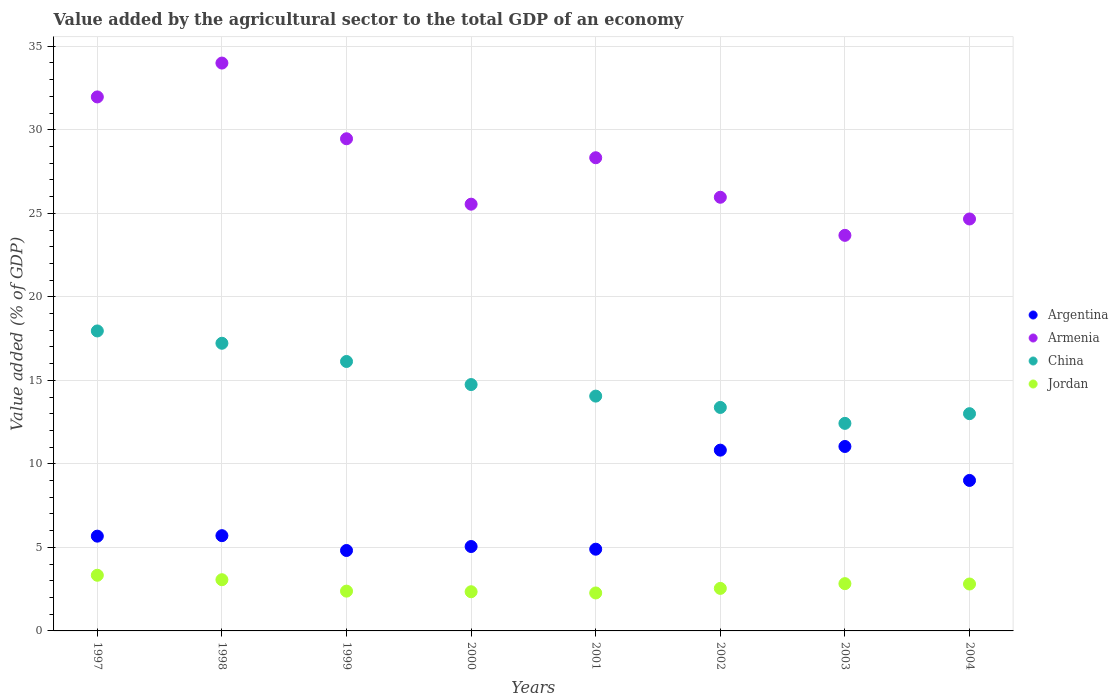What is the value added by the agricultural sector to the total GDP in Jordan in 2000?
Keep it short and to the point. 2.35. Across all years, what is the maximum value added by the agricultural sector to the total GDP in Armenia?
Your answer should be compact. 34. Across all years, what is the minimum value added by the agricultural sector to the total GDP in Jordan?
Your answer should be very brief. 2.27. In which year was the value added by the agricultural sector to the total GDP in Argentina minimum?
Provide a short and direct response. 1999. What is the total value added by the agricultural sector to the total GDP in Armenia in the graph?
Provide a succinct answer. 223.61. What is the difference between the value added by the agricultural sector to the total GDP in China in 1997 and that in 2004?
Your answer should be compact. 4.95. What is the difference between the value added by the agricultural sector to the total GDP in Argentina in 1998 and the value added by the agricultural sector to the total GDP in Armenia in 2004?
Your answer should be compact. -18.96. What is the average value added by the agricultural sector to the total GDP in Argentina per year?
Your answer should be very brief. 7.13. In the year 2003, what is the difference between the value added by the agricultural sector to the total GDP in Argentina and value added by the agricultural sector to the total GDP in Jordan?
Provide a short and direct response. 8.21. In how many years, is the value added by the agricultural sector to the total GDP in China greater than 22 %?
Ensure brevity in your answer.  0. What is the ratio of the value added by the agricultural sector to the total GDP in China in 1997 to that in 2003?
Ensure brevity in your answer.  1.45. Is the value added by the agricultural sector to the total GDP in China in 1997 less than that in 1998?
Your response must be concise. No. Is the difference between the value added by the agricultural sector to the total GDP in Argentina in 1998 and 2004 greater than the difference between the value added by the agricultural sector to the total GDP in Jordan in 1998 and 2004?
Your response must be concise. No. What is the difference between the highest and the second highest value added by the agricultural sector to the total GDP in Argentina?
Your answer should be very brief. 0.22. What is the difference between the highest and the lowest value added by the agricultural sector to the total GDP in China?
Ensure brevity in your answer.  5.53. In how many years, is the value added by the agricultural sector to the total GDP in Armenia greater than the average value added by the agricultural sector to the total GDP in Armenia taken over all years?
Provide a short and direct response. 4. Is the sum of the value added by the agricultural sector to the total GDP in Argentina in 2000 and 2004 greater than the maximum value added by the agricultural sector to the total GDP in China across all years?
Your response must be concise. No. Is it the case that in every year, the sum of the value added by the agricultural sector to the total GDP in Argentina and value added by the agricultural sector to the total GDP in Jordan  is greater than the sum of value added by the agricultural sector to the total GDP in Armenia and value added by the agricultural sector to the total GDP in China?
Your answer should be very brief. Yes. Is the value added by the agricultural sector to the total GDP in Argentina strictly less than the value added by the agricultural sector to the total GDP in China over the years?
Your answer should be very brief. Yes. How many years are there in the graph?
Your response must be concise. 8. What is the difference between two consecutive major ticks on the Y-axis?
Your response must be concise. 5. Does the graph contain any zero values?
Provide a succinct answer. No. Where does the legend appear in the graph?
Offer a very short reply. Center right. How many legend labels are there?
Make the answer very short. 4. How are the legend labels stacked?
Give a very brief answer. Vertical. What is the title of the graph?
Offer a terse response. Value added by the agricultural sector to the total GDP of an economy. What is the label or title of the Y-axis?
Provide a succinct answer. Value added (% of GDP). What is the Value added (% of GDP) of Argentina in 1997?
Make the answer very short. 5.67. What is the Value added (% of GDP) in Armenia in 1997?
Keep it short and to the point. 31.97. What is the Value added (% of GDP) of China in 1997?
Your answer should be compact. 17.96. What is the Value added (% of GDP) in Jordan in 1997?
Provide a succinct answer. 3.33. What is the Value added (% of GDP) in Argentina in 1998?
Give a very brief answer. 5.7. What is the Value added (% of GDP) in Armenia in 1998?
Your answer should be very brief. 34. What is the Value added (% of GDP) of China in 1998?
Your response must be concise. 17.22. What is the Value added (% of GDP) of Jordan in 1998?
Offer a terse response. 3.07. What is the Value added (% of GDP) of Argentina in 1999?
Offer a very short reply. 4.82. What is the Value added (% of GDP) in Armenia in 1999?
Ensure brevity in your answer.  29.46. What is the Value added (% of GDP) of China in 1999?
Give a very brief answer. 16.13. What is the Value added (% of GDP) of Jordan in 1999?
Keep it short and to the point. 2.38. What is the Value added (% of GDP) of Argentina in 2000?
Provide a succinct answer. 5.05. What is the Value added (% of GDP) of Armenia in 2000?
Make the answer very short. 25.55. What is the Value added (% of GDP) of China in 2000?
Offer a very short reply. 14.75. What is the Value added (% of GDP) of Jordan in 2000?
Provide a short and direct response. 2.35. What is the Value added (% of GDP) in Argentina in 2001?
Make the answer very short. 4.89. What is the Value added (% of GDP) of Armenia in 2001?
Your answer should be compact. 28.33. What is the Value added (% of GDP) in China in 2001?
Your answer should be compact. 14.06. What is the Value added (% of GDP) in Jordan in 2001?
Provide a short and direct response. 2.27. What is the Value added (% of GDP) of Argentina in 2002?
Provide a short and direct response. 10.82. What is the Value added (% of GDP) in Armenia in 2002?
Your answer should be compact. 25.96. What is the Value added (% of GDP) of China in 2002?
Your answer should be compact. 13.38. What is the Value added (% of GDP) of Jordan in 2002?
Your answer should be compact. 2.55. What is the Value added (% of GDP) in Argentina in 2003?
Offer a terse response. 11.04. What is the Value added (% of GDP) in Armenia in 2003?
Your answer should be compact. 23.68. What is the Value added (% of GDP) of China in 2003?
Ensure brevity in your answer.  12.43. What is the Value added (% of GDP) in Jordan in 2003?
Make the answer very short. 2.83. What is the Value added (% of GDP) of Argentina in 2004?
Offer a terse response. 9.01. What is the Value added (% of GDP) in Armenia in 2004?
Provide a short and direct response. 24.66. What is the Value added (% of GDP) in China in 2004?
Your response must be concise. 13.01. What is the Value added (% of GDP) of Jordan in 2004?
Offer a terse response. 2.81. Across all years, what is the maximum Value added (% of GDP) in Argentina?
Provide a succinct answer. 11.04. Across all years, what is the maximum Value added (% of GDP) in Armenia?
Provide a short and direct response. 34. Across all years, what is the maximum Value added (% of GDP) of China?
Provide a short and direct response. 17.96. Across all years, what is the maximum Value added (% of GDP) of Jordan?
Your answer should be very brief. 3.33. Across all years, what is the minimum Value added (% of GDP) of Argentina?
Provide a short and direct response. 4.82. Across all years, what is the minimum Value added (% of GDP) of Armenia?
Provide a short and direct response. 23.68. Across all years, what is the minimum Value added (% of GDP) in China?
Provide a succinct answer. 12.43. Across all years, what is the minimum Value added (% of GDP) in Jordan?
Make the answer very short. 2.27. What is the total Value added (% of GDP) of Argentina in the graph?
Provide a succinct answer. 57.01. What is the total Value added (% of GDP) in Armenia in the graph?
Give a very brief answer. 223.61. What is the total Value added (% of GDP) in China in the graph?
Make the answer very short. 118.93. What is the total Value added (% of GDP) of Jordan in the graph?
Your answer should be compact. 21.58. What is the difference between the Value added (% of GDP) of Argentina in 1997 and that in 1998?
Your answer should be very brief. -0.03. What is the difference between the Value added (% of GDP) of Armenia in 1997 and that in 1998?
Provide a succinct answer. -2.03. What is the difference between the Value added (% of GDP) of China in 1997 and that in 1998?
Give a very brief answer. 0.74. What is the difference between the Value added (% of GDP) of Jordan in 1997 and that in 1998?
Your response must be concise. 0.27. What is the difference between the Value added (% of GDP) of Argentina in 1997 and that in 1999?
Your answer should be compact. 0.86. What is the difference between the Value added (% of GDP) in Armenia in 1997 and that in 1999?
Give a very brief answer. 2.5. What is the difference between the Value added (% of GDP) in China in 1997 and that in 1999?
Your answer should be very brief. 1.83. What is the difference between the Value added (% of GDP) of Jordan in 1997 and that in 1999?
Keep it short and to the point. 0.95. What is the difference between the Value added (% of GDP) of Argentina in 1997 and that in 2000?
Ensure brevity in your answer.  0.62. What is the difference between the Value added (% of GDP) of Armenia in 1997 and that in 2000?
Offer a terse response. 6.42. What is the difference between the Value added (% of GDP) in China in 1997 and that in 2000?
Make the answer very short. 3.21. What is the difference between the Value added (% of GDP) of Jordan in 1997 and that in 2000?
Ensure brevity in your answer.  0.99. What is the difference between the Value added (% of GDP) in Argentina in 1997 and that in 2001?
Make the answer very short. 0.78. What is the difference between the Value added (% of GDP) of Armenia in 1997 and that in 2001?
Make the answer very short. 3.64. What is the difference between the Value added (% of GDP) in China in 1997 and that in 2001?
Offer a terse response. 3.9. What is the difference between the Value added (% of GDP) of Jordan in 1997 and that in 2001?
Provide a short and direct response. 1.06. What is the difference between the Value added (% of GDP) in Argentina in 1997 and that in 2002?
Your response must be concise. -5.15. What is the difference between the Value added (% of GDP) in Armenia in 1997 and that in 2002?
Ensure brevity in your answer.  6.01. What is the difference between the Value added (% of GDP) in China in 1997 and that in 2002?
Ensure brevity in your answer.  4.58. What is the difference between the Value added (% of GDP) of Jordan in 1997 and that in 2002?
Offer a terse response. 0.79. What is the difference between the Value added (% of GDP) in Argentina in 1997 and that in 2003?
Keep it short and to the point. -5.37. What is the difference between the Value added (% of GDP) of Armenia in 1997 and that in 2003?
Keep it short and to the point. 8.29. What is the difference between the Value added (% of GDP) in China in 1997 and that in 2003?
Your answer should be compact. 5.53. What is the difference between the Value added (% of GDP) of Jordan in 1997 and that in 2003?
Provide a succinct answer. 0.5. What is the difference between the Value added (% of GDP) in Argentina in 1997 and that in 2004?
Provide a short and direct response. -3.34. What is the difference between the Value added (% of GDP) of Armenia in 1997 and that in 2004?
Provide a short and direct response. 7.31. What is the difference between the Value added (% of GDP) in China in 1997 and that in 2004?
Your answer should be compact. 4.95. What is the difference between the Value added (% of GDP) in Jordan in 1997 and that in 2004?
Provide a succinct answer. 0.52. What is the difference between the Value added (% of GDP) in Argentina in 1998 and that in 1999?
Give a very brief answer. 0.89. What is the difference between the Value added (% of GDP) in Armenia in 1998 and that in 1999?
Your response must be concise. 4.53. What is the difference between the Value added (% of GDP) in China in 1998 and that in 1999?
Keep it short and to the point. 1.09. What is the difference between the Value added (% of GDP) of Jordan in 1998 and that in 1999?
Your answer should be compact. 0.68. What is the difference between the Value added (% of GDP) of Argentina in 1998 and that in 2000?
Your answer should be compact. 0.65. What is the difference between the Value added (% of GDP) in Armenia in 1998 and that in 2000?
Your answer should be very brief. 8.45. What is the difference between the Value added (% of GDP) of China in 1998 and that in 2000?
Your answer should be very brief. 2.47. What is the difference between the Value added (% of GDP) of Jordan in 1998 and that in 2000?
Ensure brevity in your answer.  0.72. What is the difference between the Value added (% of GDP) in Argentina in 1998 and that in 2001?
Provide a short and direct response. 0.81. What is the difference between the Value added (% of GDP) in Armenia in 1998 and that in 2001?
Provide a short and direct response. 5.67. What is the difference between the Value added (% of GDP) of China in 1998 and that in 2001?
Provide a succinct answer. 3.16. What is the difference between the Value added (% of GDP) in Jordan in 1998 and that in 2001?
Keep it short and to the point. 0.79. What is the difference between the Value added (% of GDP) of Argentina in 1998 and that in 2002?
Your answer should be very brief. -5.12. What is the difference between the Value added (% of GDP) of Armenia in 1998 and that in 2002?
Keep it short and to the point. 8.03. What is the difference between the Value added (% of GDP) of China in 1998 and that in 2002?
Your answer should be very brief. 3.84. What is the difference between the Value added (% of GDP) of Jordan in 1998 and that in 2002?
Offer a very short reply. 0.52. What is the difference between the Value added (% of GDP) of Argentina in 1998 and that in 2003?
Provide a short and direct response. -5.34. What is the difference between the Value added (% of GDP) in Armenia in 1998 and that in 2003?
Ensure brevity in your answer.  10.31. What is the difference between the Value added (% of GDP) of China in 1998 and that in 2003?
Make the answer very short. 4.8. What is the difference between the Value added (% of GDP) in Jordan in 1998 and that in 2003?
Your answer should be very brief. 0.24. What is the difference between the Value added (% of GDP) of Argentina in 1998 and that in 2004?
Your answer should be compact. -3.31. What is the difference between the Value added (% of GDP) of Armenia in 1998 and that in 2004?
Keep it short and to the point. 9.33. What is the difference between the Value added (% of GDP) of China in 1998 and that in 2004?
Offer a very short reply. 4.22. What is the difference between the Value added (% of GDP) in Jordan in 1998 and that in 2004?
Offer a very short reply. 0.26. What is the difference between the Value added (% of GDP) of Argentina in 1999 and that in 2000?
Your answer should be very brief. -0.24. What is the difference between the Value added (% of GDP) in Armenia in 1999 and that in 2000?
Ensure brevity in your answer.  3.92. What is the difference between the Value added (% of GDP) of China in 1999 and that in 2000?
Give a very brief answer. 1.38. What is the difference between the Value added (% of GDP) of Jordan in 1999 and that in 2000?
Provide a short and direct response. 0.04. What is the difference between the Value added (% of GDP) of Argentina in 1999 and that in 2001?
Offer a very short reply. -0.08. What is the difference between the Value added (% of GDP) in Armenia in 1999 and that in 2001?
Ensure brevity in your answer.  1.14. What is the difference between the Value added (% of GDP) in China in 1999 and that in 2001?
Provide a succinct answer. 2.07. What is the difference between the Value added (% of GDP) in Jordan in 1999 and that in 2001?
Your answer should be very brief. 0.11. What is the difference between the Value added (% of GDP) in Argentina in 1999 and that in 2002?
Make the answer very short. -6.01. What is the difference between the Value added (% of GDP) in Armenia in 1999 and that in 2002?
Your answer should be compact. 3.5. What is the difference between the Value added (% of GDP) of China in 1999 and that in 2002?
Your answer should be compact. 2.75. What is the difference between the Value added (% of GDP) of Jordan in 1999 and that in 2002?
Your answer should be compact. -0.16. What is the difference between the Value added (% of GDP) of Argentina in 1999 and that in 2003?
Your response must be concise. -6.23. What is the difference between the Value added (% of GDP) of Armenia in 1999 and that in 2003?
Provide a short and direct response. 5.78. What is the difference between the Value added (% of GDP) in China in 1999 and that in 2003?
Offer a terse response. 3.71. What is the difference between the Value added (% of GDP) of Jordan in 1999 and that in 2003?
Provide a short and direct response. -0.45. What is the difference between the Value added (% of GDP) in Argentina in 1999 and that in 2004?
Provide a succinct answer. -4.19. What is the difference between the Value added (% of GDP) of Armenia in 1999 and that in 2004?
Offer a terse response. 4.8. What is the difference between the Value added (% of GDP) in China in 1999 and that in 2004?
Make the answer very short. 3.13. What is the difference between the Value added (% of GDP) in Jordan in 1999 and that in 2004?
Make the answer very short. -0.43. What is the difference between the Value added (% of GDP) in Argentina in 2000 and that in 2001?
Give a very brief answer. 0.16. What is the difference between the Value added (% of GDP) in Armenia in 2000 and that in 2001?
Your answer should be very brief. -2.78. What is the difference between the Value added (% of GDP) in China in 2000 and that in 2001?
Your answer should be compact. 0.69. What is the difference between the Value added (% of GDP) of Jordan in 2000 and that in 2001?
Your answer should be compact. 0.07. What is the difference between the Value added (% of GDP) of Argentina in 2000 and that in 2002?
Make the answer very short. -5.77. What is the difference between the Value added (% of GDP) in Armenia in 2000 and that in 2002?
Provide a short and direct response. -0.41. What is the difference between the Value added (% of GDP) in China in 2000 and that in 2002?
Your answer should be compact. 1.37. What is the difference between the Value added (% of GDP) of Jordan in 2000 and that in 2002?
Your answer should be very brief. -0.2. What is the difference between the Value added (% of GDP) in Argentina in 2000 and that in 2003?
Your answer should be compact. -5.99. What is the difference between the Value added (% of GDP) of Armenia in 2000 and that in 2003?
Provide a short and direct response. 1.87. What is the difference between the Value added (% of GDP) in China in 2000 and that in 2003?
Your response must be concise. 2.32. What is the difference between the Value added (% of GDP) of Jordan in 2000 and that in 2003?
Your answer should be compact. -0.48. What is the difference between the Value added (% of GDP) in Argentina in 2000 and that in 2004?
Keep it short and to the point. -3.96. What is the difference between the Value added (% of GDP) in Armenia in 2000 and that in 2004?
Make the answer very short. 0.89. What is the difference between the Value added (% of GDP) in China in 2000 and that in 2004?
Give a very brief answer. 1.74. What is the difference between the Value added (% of GDP) of Jordan in 2000 and that in 2004?
Make the answer very short. -0.46. What is the difference between the Value added (% of GDP) of Argentina in 2001 and that in 2002?
Offer a very short reply. -5.93. What is the difference between the Value added (% of GDP) in Armenia in 2001 and that in 2002?
Your answer should be compact. 2.37. What is the difference between the Value added (% of GDP) in China in 2001 and that in 2002?
Ensure brevity in your answer.  0.68. What is the difference between the Value added (% of GDP) of Jordan in 2001 and that in 2002?
Offer a terse response. -0.27. What is the difference between the Value added (% of GDP) of Argentina in 2001 and that in 2003?
Offer a very short reply. -6.15. What is the difference between the Value added (% of GDP) in Armenia in 2001 and that in 2003?
Give a very brief answer. 4.65. What is the difference between the Value added (% of GDP) in China in 2001 and that in 2003?
Give a very brief answer. 1.63. What is the difference between the Value added (% of GDP) of Jordan in 2001 and that in 2003?
Provide a succinct answer. -0.56. What is the difference between the Value added (% of GDP) of Argentina in 2001 and that in 2004?
Your answer should be compact. -4.12. What is the difference between the Value added (% of GDP) of Armenia in 2001 and that in 2004?
Provide a short and direct response. 3.67. What is the difference between the Value added (% of GDP) in China in 2001 and that in 2004?
Offer a very short reply. 1.05. What is the difference between the Value added (% of GDP) in Jordan in 2001 and that in 2004?
Your answer should be very brief. -0.54. What is the difference between the Value added (% of GDP) of Argentina in 2002 and that in 2003?
Your answer should be very brief. -0.22. What is the difference between the Value added (% of GDP) in Armenia in 2002 and that in 2003?
Offer a very short reply. 2.28. What is the difference between the Value added (% of GDP) of China in 2002 and that in 2003?
Your answer should be compact. 0.95. What is the difference between the Value added (% of GDP) of Jordan in 2002 and that in 2003?
Keep it short and to the point. -0.28. What is the difference between the Value added (% of GDP) of Argentina in 2002 and that in 2004?
Make the answer very short. 1.81. What is the difference between the Value added (% of GDP) in Armenia in 2002 and that in 2004?
Provide a short and direct response. 1.3. What is the difference between the Value added (% of GDP) of China in 2002 and that in 2004?
Your answer should be very brief. 0.37. What is the difference between the Value added (% of GDP) of Jordan in 2002 and that in 2004?
Your answer should be compact. -0.26. What is the difference between the Value added (% of GDP) in Argentina in 2003 and that in 2004?
Ensure brevity in your answer.  2.03. What is the difference between the Value added (% of GDP) of Armenia in 2003 and that in 2004?
Offer a terse response. -0.98. What is the difference between the Value added (% of GDP) of China in 2003 and that in 2004?
Make the answer very short. -0.58. What is the difference between the Value added (% of GDP) of Jordan in 2003 and that in 2004?
Keep it short and to the point. 0.02. What is the difference between the Value added (% of GDP) of Argentina in 1997 and the Value added (% of GDP) of Armenia in 1998?
Offer a very short reply. -28.32. What is the difference between the Value added (% of GDP) in Argentina in 1997 and the Value added (% of GDP) in China in 1998?
Make the answer very short. -11.55. What is the difference between the Value added (% of GDP) in Argentina in 1997 and the Value added (% of GDP) in Jordan in 1998?
Ensure brevity in your answer.  2.61. What is the difference between the Value added (% of GDP) in Armenia in 1997 and the Value added (% of GDP) in China in 1998?
Offer a very short reply. 14.75. What is the difference between the Value added (% of GDP) of Armenia in 1997 and the Value added (% of GDP) of Jordan in 1998?
Ensure brevity in your answer.  28.9. What is the difference between the Value added (% of GDP) of China in 1997 and the Value added (% of GDP) of Jordan in 1998?
Your answer should be very brief. 14.89. What is the difference between the Value added (% of GDP) in Argentina in 1997 and the Value added (% of GDP) in Armenia in 1999?
Make the answer very short. -23.79. What is the difference between the Value added (% of GDP) of Argentina in 1997 and the Value added (% of GDP) of China in 1999?
Your answer should be compact. -10.46. What is the difference between the Value added (% of GDP) in Argentina in 1997 and the Value added (% of GDP) in Jordan in 1999?
Your answer should be compact. 3.29. What is the difference between the Value added (% of GDP) of Armenia in 1997 and the Value added (% of GDP) of China in 1999?
Your answer should be very brief. 15.84. What is the difference between the Value added (% of GDP) in Armenia in 1997 and the Value added (% of GDP) in Jordan in 1999?
Provide a short and direct response. 29.59. What is the difference between the Value added (% of GDP) of China in 1997 and the Value added (% of GDP) of Jordan in 1999?
Keep it short and to the point. 15.58. What is the difference between the Value added (% of GDP) in Argentina in 1997 and the Value added (% of GDP) in Armenia in 2000?
Keep it short and to the point. -19.87. What is the difference between the Value added (% of GDP) of Argentina in 1997 and the Value added (% of GDP) of China in 2000?
Your response must be concise. -9.08. What is the difference between the Value added (% of GDP) in Argentina in 1997 and the Value added (% of GDP) in Jordan in 2000?
Provide a short and direct response. 3.33. What is the difference between the Value added (% of GDP) in Armenia in 1997 and the Value added (% of GDP) in China in 2000?
Your answer should be very brief. 17.22. What is the difference between the Value added (% of GDP) in Armenia in 1997 and the Value added (% of GDP) in Jordan in 2000?
Your answer should be compact. 29.62. What is the difference between the Value added (% of GDP) in China in 1997 and the Value added (% of GDP) in Jordan in 2000?
Offer a very short reply. 15.61. What is the difference between the Value added (% of GDP) in Argentina in 1997 and the Value added (% of GDP) in Armenia in 2001?
Your answer should be very brief. -22.65. What is the difference between the Value added (% of GDP) in Argentina in 1997 and the Value added (% of GDP) in China in 2001?
Provide a short and direct response. -8.38. What is the difference between the Value added (% of GDP) of Argentina in 1997 and the Value added (% of GDP) of Jordan in 2001?
Offer a terse response. 3.4. What is the difference between the Value added (% of GDP) in Armenia in 1997 and the Value added (% of GDP) in China in 2001?
Provide a succinct answer. 17.91. What is the difference between the Value added (% of GDP) in Armenia in 1997 and the Value added (% of GDP) in Jordan in 2001?
Provide a short and direct response. 29.7. What is the difference between the Value added (% of GDP) of China in 1997 and the Value added (% of GDP) of Jordan in 2001?
Provide a short and direct response. 15.69. What is the difference between the Value added (% of GDP) of Argentina in 1997 and the Value added (% of GDP) of Armenia in 2002?
Ensure brevity in your answer.  -20.29. What is the difference between the Value added (% of GDP) in Argentina in 1997 and the Value added (% of GDP) in China in 2002?
Ensure brevity in your answer.  -7.71. What is the difference between the Value added (% of GDP) in Argentina in 1997 and the Value added (% of GDP) in Jordan in 2002?
Your answer should be very brief. 3.13. What is the difference between the Value added (% of GDP) of Armenia in 1997 and the Value added (% of GDP) of China in 2002?
Offer a very short reply. 18.59. What is the difference between the Value added (% of GDP) of Armenia in 1997 and the Value added (% of GDP) of Jordan in 2002?
Offer a very short reply. 29.42. What is the difference between the Value added (% of GDP) of China in 1997 and the Value added (% of GDP) of Jordan in 2002?
Offer a terse response. 15.41. What is the difference between the Value added (% of GDP) of Argentina in 1997 and the Value added (% of GDP) of Armenia in 2003?
Provide a short and direct response. -18.01. What is the difference between the Value added (% of GDP) of Argentina in 1997 and the Value added (% of GDP) of China in 2003?
Your response must be concise. -6.75. What is the difference between the Value added (% of GDP) in Argentina in 1997 and the Value added (% of GDP) in Jordan in 2003?
Give a very brief answer. 2.84. What is the difference between the Value added (% of GDP) of Armenia in 1997 and the Value added (% of GDP) of China in 2003?
Offer a terse response. 19.54. What is the difference between the Value added (% of GDP) of Armenia in 1997 and the Value added (% of GDP) of Jordan in 2003?
Offer a terse response. 29.14. What is the difference between the Value added (% of GDP) in China in 1997 and the Value added (% of GDP) in Jordan in 2003?
Your answer should be compact. 15.13. What is the difference between the Value added (% of GDP) of Argentina in 1997 and the Value added (% of GDP) of Armenia in 2004?
Give a very brief answer. -18.99. What is the difference between the Value added (% of GDP) of Argentina in 1997 and the Value added (% of GDP) of China in 2004?
Keep it short and to the point. -7.33. What is the difference between the Value added (% of GDP) of Argentina in 1997 and the Value added (% of GDP) of Jordan in 2004?
Keep it short and to the point. 2.86. What is the difference between the Value added (% of GDP) of Armenia in 1997 and the Value added (% of GDP) of China in 2004?
Your response must be concise. 18.96. What is the difference between the Value added (% of GDP) of Armenia in 1997 and the Value added (% of GDP) of Jordan in 2004?
Offer a very short reply. 29.16. What is the difference between the Value added (% of GDP) of China in 1997 and the Value added (% of GDP) of Jordan in 2004?
Make the answer very short. 15.15. What is the difference between the Value added (% of GDP) of Argentina in 1998 and the Value added (% of GDP) of Armenia in 1999?
Give a very brief answer. -23.76. What is the difference between the Value added (% of GDP) of Argentina in 1998 and the Value added (% of GDP) of China in 1999?
Provide a short and direct response. -10.43. What is the difference between the Value added (% of GDP) in Argentina in 1998 and the Value added (% of GDP) in Jordan in 1999?
Your response must be concise. 3.32. What is the difference between the Value added (% of GDP) in Armenia in 1998 and the Value added (% of GDP) in China in 1999?
Make the answer very short. 17.86. What is the difference between the Value added (% of GDP) of Armenia in 1998 and the Value added (% of GDP) of Jordan in 1999?
Provide a succinct answer. 31.61. What is the difference between the Value added (% of GDP) in China in 1998 and the Value added (% of GDP) in Jordan in 1999?
Your answer should be very brief. 14.84. What is the difference between the Value added (% of GDP) of Argentina in 1998 and the Value added (% of GDP) of Armenia in 2000?
Your answer should be very brief. -19.84. What is the difference between the Value added (% of GDP) of Argentina in 1998 and the Value added (% of GDP) of China in 2000?
Provide a short and direct response. -9.05. What is the difference between the Value added (% of GDP) of Argentina in 1998 and the Value added (% of GDP) of Jordan in 2000?
Keep it short and to the point. 3.36. What is the difference between the Value added (% of GDP) of Armenia in 1998 and the Value added (% of GDP) of China in 2000?
Give a very brief answer. 19.25. What is the difference between the Value added (% of GDP) of Armenia in 1998 and the Value added (% of GDP) of Jordan in 2000?
Provide a short and direct response. 31.65. What is the difference between the Value added (% of GDP) of China in 1998 and the Value added (% of GDP) of Jordan in 2000?
Your response must be concise. 14.88. What is the difference between the Value added (% of GDP) of Argentina in 1998 and the Value added (% of GDP) of Armenia in 2001?
Offer a very short reply. -22.63. What is the difference between the Value added (% of GDP) in Argentina in 1998 and the Value added (% of GDP) in China in 2001?
Your answer should be compact. -8.35. What is the difference between the Value added (% of GDP) in Argentina in 1998 and the Value added (% of GDP) in Jordan in 2001?
Give a very brief answer. 3.43. What is the difference between the Value added (% of GDP) of Armenia in 1998 and the Value added (% of GDP) of China in 2001?
Keep it short and to the point. 19.94. What is the difference between the Value added (% of GDP) of Armenia in 1998 and the Value added (% of GDP) of Jordan in 2001?
Your answer should be very brief. 31.72. What is the difference between the Value added (% of GDP) in China in 1998 and the Value added (% of GDP) in Jordan in 2001?
Ensure brevity in your answer.  14.95. What is the difference between the Value added (% of GDP) in Argentina in 1998 and the Value added (% of GDP) in Armenia in 2002?
Provide a succinct answer. -20.26. What is the difference between the Value added (% of GDP) of Argentina in 1998 and the Value added (% of GDP) of China in 2002?
Make the answer very short. -7.68. What is the difference between the Value added (% of GDP) of Argentina in 1998 and the Value added (% of GDP) of Jordan in 2002?
Give a very brief answer. 3.16. What is the difference between the Value added (% of GDP) in Armenia in 1998 and the Value added (% of GDP) in China in 2002?
Keep it short and to the point. 20.62. What is the difference between the Value added (% of GDP) of Armenia in 1998 and the Value added (% of GDP) of Jordan in 2002?
Give a very brief answer. 31.45. What is the difference between the Value added (% of GDP) of China in 1998 and the Value added (% of GDP) of Jordan in 2002?
Make the answer very short. 14.68. What is the difference between the Value added (% of GDP) in Argentina in 1998 and the Value added (% of GDP) in Armenia in 2003?
Offer a very short reply. -17.98. What is the difference between the Value added (% of GDP) in Argentina in 1998 and the Value added (% of GDP) in China in 2003?
Provide a short and direct response. -6.72. What is the difference between the Value added (% of GDP) of Argentina in 1998 and the Value added (% of GDP) of Jordan in 2003?
Your answer should be very brief. 2.87. What is the difference between the Value added (% of GDP) in Armenia in 1998 and the Value added (% of GDP) in China in 2003?
Your response must be concise. 21.57. What is the difference between the Value added (% of GDP) of Armenia in 1998 and the Value added (% of GDP) of Jordan in 2003?
Keep it short and to the point. 31.17. What is the difference between the Value added (% of GDP) in China in 1998 and the Value added (% of GDP) in Jordan in 2003?
Provide a succinct answer. 14.39. What is the difference between the Value added (% of GDP) in Argentina in 1998 and the Value added (% of GDP) in Armenia in 2004?
Your answer should be compact. -18.96. What is the difference between the Value added (% of GDP) in Argentina in 1998 and the Value added (% of GDP) in China in 2004?
Provide a short and direct response. -7.3. What is the difference between the Value added (% of GDP) in Argentina in 1998 and the Value added (% of GDP) in Jordan in 2004?
Your answer should be compact. 2.89. What is the difference between the Value added (% of GDP) of Armenia in 1998 and the Value added (% of GDP) of China in 2004?
Offer a very short reply. 20.99. What is the difference between the Value added (% of GDP) in Armenia in 1998 and the Value added (% of GDP) in Jordan in 2004?
Offer a terse response. 31.19. What is the difference between the Value added (% of GDP) in China in 1998 and the Value added (% of GDP) in Jordan in 2004?
Provide a short and direct response. 14.41. What is the difference between the Value added (% of GDP) in Argentina in 1999 and the Value added (% of GDP) in Armenia in 2000?
Your response must be concise. -20.73. What is the difference between the Value added (% of GDP) of Argentina in 1999 and the Value added (% of GDP) of China in 2000?
Keep it short and to the point. -9.93. What is the difference between the Value added (% of GDP) in Argentina in 1999 and the Value added (% of GDP) in Jordan in 2000?
Make the answer very short. 2.47. What is the difference between the Value added (% of GDP) of Armenia in 1999 and the Value added (% of GDP) of China in 2000?
Offer a terse response. 14.71. What is the difference between the Value added (% of GDP) of Armenia in 1999 and the Value added (% of GDP) of Jordan in 2000?
Ensure brevity in your answer.  27.12. What is the difference between the Value added (% of GDP) of China in 1999 and the Value added (% of GDP) of Jordan in 2000?
Your response must be concise. 13.79. What is the difference between the Value added (% of GDP) of Argentina in 1999 and the Value added (% of GDP) of Armenia in 2001?
Your answer should be very brief. -23.51. What is the difference between the Value added (% of GDP) in Argentina in 1999 and the Value added (% of GDP) in China in 2001?
Provide a short and direct response. -9.24. What is the difference between the Value added (% of GDP) in Argentina in 1999 and the Value added (% of GDP) in Jordan in 2001?
Provide a succinct answer. 2.54. What is the difference between the Value added (% of GDP) in Armenia in 1999 and the Value added (% of GDP) in China in 2001?
Your answer should be compact. 15.41. What is the difference between the Value added (% of GDP) of Armenia in 1999 and the Value added (% of GDP) of Jordan in 2001?
Provide a succinct answer. 27.19. What is the difference between the Value added (% of GDP) in China in 1999 and the Value added (% of GDP) in Jordan in 2001?
Make the answer very short. 13.86. What is the difference between the Value added (% of GDP) of Argentina in 1999 and the Value added (% of GDP) of Armenia in 2002?
Give a very brief answer. -21.15. What is the difference between the Value added (% of GDP) in Argentina in 1999 and the Value added (% of GDP) in China in 2002?
Make the answer very short. -8.56. What is the difference between the Value added (% of GDP) of Argentina in 1999 and the Value added (% of GDP) of Jordan in 2002?
Provide a succinct answer. 2.27. What is the difference between the Value added (% of GDP) in Armenia in 1999 and the Value added (% of GDP) in China in 2002?
Offer a very short reply. 16.09. What is the difference between the Value added (% of GDP) of Armenia in 1999 and the Value added (% of GDP) of Jordan in 2002?
Offer a very short reply. 26.92. What is the difference between the Value added (% of GDP) in China in 1999 and the Value added (% of GDP) in Jordan in 2002?
Ensure brevity in your answer.  13.58. What is the difference between the Value added (% of GDP) in Argentina in 1999 and the Value added (% of GDP) in Armenia in 2003?
Make the answer very short. -18.87. What is the difference between the Value added (% of GDP) in Argentina in 1999 and the Value added (% of GDP) in China in 2003?
Offer a terse response. -7.61. What is the difference between the Value added (% of GDP) in Argentina in 1999 and the Value added (% of GDP) in Jordan in 2003?
Offer a very short reply. 1.99. What is the difference between the Value added (% of GDP) of Armenia in 1999 and the Value added (% of GDP) of China in 2003?
Ensure brevity in your answer.  17.04. What is the difference between the Value added (% of GDP) of Armenia in 1999 and the Value added (% of GDP) of Jordan in 2003?
Make the answer very short. 26.63. What is the difference between the Value added (% of GDP) of China in 1999 and the Value added (% of GDP) of Jordan in 2003?
Provide a short and direct response. 13.3. What is the difference between the Value added (% of GDP) in Argentina in 1999 and the Value added (% of GDP) in Armenia in 2004?
Ensure brevity in your answer.  -19.85. What is the difference between the Value added (% of GDP) of Argentina in 1999 and the Value added (% of GDP) of China in 2004?
Offer a very short reply. -8.19. What is the difference between the Value added (% of GDP) in Argentina in 1999 and the Value added (% of GDP) in Jordan in 2004?
Your answer should be very brief. 2.01. What is the difference between the Value added (% of GDP) in Armenia in 1999 and the Value added (% of GDP) in China in 2004?
Provide a succinct answer. 16.46. What is the difference between the Value added (% of GDP) in Armenia in 1999 and the Value added (% of GDP) in Jordan in 2004?
Give a very brief answer. 26.66. What is the difference between the Value added (% of GDP) of China in 1999 and the Value added (% of GDP) of Jordan in 2004?
Ensure brevity in your answer.  13.32. What is the difference between the Value added (% of GDP) of Argentina in 2000 and the Value added (% of GDP) of Armenia in 2001?
Provide a succinct answer. -23.28. What is the difference between the Value added (% of GDP) of Argentina in 2000 and the Value added (% of GDP) of China in 2001?
Offer a very short reply. -9. What is the difference between the Value added (% of GDP) in Argentina in 2000 and the Value added (% of GDP) in Jordan in 2001?
Offer a terse response. 2.78. What is the difference between the Value added (% of GDP) of Armenia in 2000 and the Value added (% of GDP) of China in 2001?
Give a very brief answer. 11.49. What is the difference between the Value added (% of GDP) of Armenia in 2000 and the Value added (% of GDP) of Jordan in 2001?
Offer a terse response. 23.27. What is the difference between the Value added (% of GDP) in China in 2000 and the Value added (% of GDP) in Jordan in 2001?
Offer a terse response. 12.48. What is the difference between the Value added (% of GDP) of Argentina in 2000 and the Value added (% of GDP) of Armenia in 2002?
Give a very brief answer. -20.91. What is the difference between the Value added (% of GDP) in Argentina in 2000 and the Value added (% of GDP) in China in 2002?
Keep it short and to the point. -8.33. What is the difference between the Value added (% of GDP) in Argentina in 2000 and the Value added (% of GDP) in Jordan in 2002?
Your answer should be compact. 2.51. What is the difference between the Value added (% of GDP) in Armenia in 2000 and the Value added (% of GDP) in China in 2002?
Make the answer very short. 12.17. What is the difference between the Value added (% of GDP) of Armenia in 2000 and the Value added (% of GDP) of Jordan in 2002?
Offer a terse response. 23. What is the difference between the Value added (% of GDP) of China in 2000 and the Value added (% of GDP) of Jordan in 2002?
Your response must be concise. 12.2. What is the difference between the Value added (% of GDP) of Argentina in 2000 and the Value added (% of GDP) of Armenia in 2003?
Offer a very short reply. -18.63. What is the difference between the Value added (% of GDP) of Argentina in 2000 and the Value added (% of GDP) of China in 2003?
Your answer should be very brief. -7.37. What is the difference between the Value added (% of GDP) of Argentina in 2000 and the Value added (% of GDP) of Jordan in 2003?
Ensure brevity in your answer.  2.22. What is the difference between the Value added (% of GDP) in Armenia in 2000 and the Value added (% of GDP) in China in 2003?
Give a very brief answer. 13.12. What is the difference between the Value added (% of GDP) of Armenia in 2000 and the Value added (% of GDP) of Jordan in 2003?
Ensure brevity in your answer.  22.72. What is the difference between the Value added (% of GDP) in China in 2000 and the Value added (% of GDP) in Jordan in 2003?
Offer a terse response. 11.92. What is the difference between the Value added (% of GDP) in Argentina in 2000 and the Value added (% of GDP) in Armenia in 2004?
Your answer should be compact. -19.61. What is the difference between the Value added (% of GDP) in Argentina in 2000 and the Value added (% of GDP) in China in 2004?
Give a very brief answer. -7.95. What is the difference between the Value added (% of GDP) in Argentina in 2000 and the Value added (% of GDP) in Jordan in 2004?
Offer a very short reply. 2.24. What is the difference between the Value added (% of GDP) in Armenia in 2000 and the Value added (% of GDP) in China in 2004?
Provide a succinct answer. 12.54. What is the difference between the Value added (% of GDP) of Armenia in 2000 and the Value added (% of GDP) of Jordan in 2004?
Offer a terse response. 22.74. What is the difference between the Value added (% of GDP) in China in 2000 and the Value added (% of GDP) in Jordan in 2004?
Offer a terse response. 11.94. What is the difference between the Value added (% of GDP) of Argentina in 2001 and the Value added (% of GDP) of Armenia in 2002?
Make the answer very short. -21.07. What is the difference between the Value added (% of GDP) in Argentina in 2001 and the Value added (% of GDP) in China in 2002?
Provide a succinct answer. -8.49. What is the difference between the Value added (% of GDP) in Argentina in 2001 and the Value added (% of GDP) in Jordan in 2002?
Your answer should be compact. 2.35. What is the difference between the Value added (% of GDP) in Armenia in 2001 and the Value added (% of GDP) in China in 2002?
Offer a terse response. 14.95. What is the difference between the Value added (% of GDP) of Armenia in 2001 and the Value added (% of GDP) of Jordan in 2002?
Give a very brief answer. 25.78. What is the difference between the Value added (% of GDP) in China in 2001 and the Value added (% of GDP) in Jordan in 2002?
Your response must be concise. 11.51. What is the difference between the Value added (% of GDP) of Argentina in 2001 and the Value added (% of GDP) of Armenia in 2003?
Offer a terse response. -18.79. What is the difference between the Value added (% of GDP) in Argentina in 2001 and the Value added (% of GDP) in China in 2003?
Make the answer very short. -7.53. What is the difference between the Value added (% of GDP) in Argentina in 2001 and the Value added (% of GDP) in Jordan in 2003?
Keep it short and to the point. 2.06. What is the difference between the Value added (% of GDP) of Armenia in 2001 and the Value added (% of GDP) of China in 2003?
Your answer should be very brief. 15.9. What is the difference between the Value added (% of GDP) in Armenia in 2001 and the Value added (% of GDP) in Jordan in 2003?
Offer a terse response. 25.5. What is the difference between the Value added (% of GDP) of China in 2001 and the Value added (% of GDP) of Jordan in 2003?
Keep it short and to the point. 11.23. What is the difference between the Value added (% of GDP) in Argentina in 2001 and the Value added (% of GDP) in Armenia in 2004?
Provide a short and direct response. -19.77. What is the difference between the Value added (% of GDP) in Argentina in 2001 and the Value added (% of GDP) in China in 2004?
Provide a succinct answer. -8.11. What is the difference between the Value added (% of GDP) in Argentina in 2001 and the Value added (% of GDP) in Jordan in 2004?
Offer a very short reply. 2.08. What is the difference between the Value added (% of GDP) in Armenia in 2001 and the Value added (% of GDP) in China in 2004?
Keep it short and to the point. 15.32. What is the difference between the Value added (% of GDP) in Armenia in 2001 and the Value added (% of GDP) in Jordan in 2004?
Your answer should be compact. 25.52. What is the difference between the Value added (% of GDP) of China in 2001 and the Value added (% of GDP) of Jordan in 2004?
Ensure brevity in your answer.  11.25. What is the difference between the Value added (% of GDP) in Argentina in 2002 and the Value added (% of GDP) in Armenia in 2003?
Provide a succinct answer. -12.86. What is the difference between the Value added (% of GDP) of Argentina in 2002 and the Value added (% of GDP) of China in 2003?
Make the answer very short. -1.6. What is the difference between the Value added (% of GDP) in Argentina in 2002 and the Value added (% of GDP) in Jordan in 2003?
Offer a terse response. 7.99. What is the difference between the Value added (% of GDP) in Armenia in 2002 and the Value added (% of GDP) in China in 2003?
Keep it short and to the point. 13.54. What is the difference between the Value added (% of GDP) in Armenia in 2002 and the Value added (% of GDP) in Jordan in 2003?
Your answer should be very brief. 23.13. What is the difference between the Value added (% of GDP) of China in 2002 and the Value added (% of GDP) of Jordan in 2003?
Provide a succinct answer. 10.55. What is the difference between the Value added (% of GDP) of Argentina in 2002 and the Value added (% of GDP) of Armenia in 2004?
Your answer should be compact. -13.84. What is the difference between the Value added (% of GDP) of Argentina in 2002 and the Value added (% of GDP) of China in 2004?
Your response must be concise. -2.18. What is the difference between the Value added (% of GDP) in Argentina in 2002 and the Value added (% of GDP) in Jordan in 2004?
Your answer should be compact. 8.01. What is the difference between the Value added (% of GDP) of Armenia in 2002 and the Value added (% of GDP) of China in 2004?
Offer a terse response. 12.96. What is the difference between the Value added (% of GDP) of Armenia in 2002 and the Value added (% of GDP) of Jordan in 2004?
Your answer should be compact. 23.15. What is the difference between the Value added (% of GDP) in China in 2002 and the Value added (% of GDP) in Jordan in 2004?
Keep it short and to the point. 10.57. What is the difference between the Value added (% of GDP) in Argentina in 2003 and the Value added (% of GDP) in Armenia in 2004?
Ensure brevity in your answer.  -13.62. What is the difference between the Value added (% of GDP) of Argentina in 2003 and the Value added (% of GDP) of China in 2004?
Make the answer very short. -1.96. What is the difference between the Value added (% of GDP) of Argentina in 2003 and the Value added (% of GDP) of Jordan in 2004?
Your answer should be very brief. 8.23. What is the difference between the Value added (% of GDP) of Armenia in 2003 and the Value added (% of GDP) of China in 2004?
Your answer should be very brief. 10.68. What is the difference between the Value added (% of GDP) in Armenia in 2003 and the Value added (% of GDP) in Jordan in 2004?
Provide a succinct answer. 20.87. What is the difference between the Value added (% of GDP) of China in 2003 and the Value added (% of GDP) of Jordan in 2004?
Your response must be concise. 9.62. What is the average Value added (% of GDP) in Argentina per year?
Your answer should be compact. 7.13. What is the average Value added (% of GDP) of Armenia per year?
Your answer should be compact. 27.95. What is the average Value added (% of GDP) of China per year?
Ensure brevity in your answer.  14.87. What is the average Value added (% of GDP) of Jordan per year?
Keep it short and to the point. 2.7. In the year 1997, what is the difference between the Value added (% of GDP) of Argentina and Value added (% of GDP) of Armenia?
Provide a succinct answer. -26.3. In the year 1997, what is the difference between the Value added (% of GDP) in Argentina and Value added (% of GDP) in China?
Offer a very short reply. -12.29. In the year 1997, what is the difference between the Value added (% of GDP) in Argentina and Value added (% of GDP) in Jordan?
Your response must be concise. 2.34. In the year 1997, what is the difference between the Value added (% of GDP) of Armenia and Value added (% of GDP) of China?
Offer a terse response. 14.01. In the year 1997, what is the difference between the Value added (% of GDP) of Armenia and Value added (% of GDP) of Jordan?
Give a very brief answer. 28.64. In the year 1997, what is the difference between the Value added (% of GDP) in China and Value added (% of GDP) in Jordan?
Make the answer very short. 14.63. In the year 1998, what is the difference between the Value added (% of GDP) of Argentina and Value added (% of GDP) of Armenia?
Ensure brevity in your answer.  -28.29. In the year 1998, what is the difference between the Value added (% of GDP) in Argentina and Value added (% of GDP) in China?
Provide a succinct answer. -11.52. In the year 1998, what is the difference between the Value added (% of GDP) of Argentina and Value added (% of GDP) of Jordan?
Keep it short and to the point. 2.64. In the year 1998, what is the difference between the Value added (% of GDP) in Armenia and Value added (% of GDP) in China?
Provide a succinct answer. 16.77. In the year 1998, what is the difference between the Value added (% of GDP) in Armenia and Value added (% of GDP) in Jordan?
Offer a very short reply. 30.93. In the year 1998, what is the difference between the Value added (% of GDP) of China and Value added (% of GDP) of Jordan?
Make the answer very short. 14.16. In the year 1999, what is the difference between the Value added (% of GDP) in Argentina and Value added (% of GDP) in Armenia?
Provide a succinct answer. -24.65. In the year 1999, what is the difference between the Value added (% of GDP) of Argentina and Value added (% of GDP) of China?
Your response must be concise. -11.32. In the year 1999, what is the difference between the Value added (% of GDP) of Argentina and Value added (% of GDP) of Jordan?
Your answer should be compact. 2.43. In the year 1999, what is the difference between the Value added (% of GDP) of Armenia and Value added (% of GDP) of China?
Offer a terse response. 13.33. In the year 1999, what is the difference between the Value added (% of GDP) of Armenia and Value added (% of GDP) of Jordan?
Provide a succinct answer. 27.08. In the year 1999, what is the difference between the Value added (% of GDP) of China and Value added (% of GDP) of Jordan?
Offer a very short reply. 13.75. In the year 2000, what is the difference between the Value added (% of GDP) in Argentina and Value added (% of GDP) in Armenia?
Your answer should be compact. -20.49. In the year 2000, what is the difference between the Value added (% of GDP) of Argentina and Value added (% of GDP) of China?
Provide a succinct answer. -9.7. In the year 2000, what is the difference between the Value added (% of GDP) of Argentina and Value added (% of GDP) of Jordan?
Make the answer very short. 2.71. In the year 2000, what is the difference between the Value added (% of GDP) in Armenia and Value added (% of GDP) in China?
Offer a very short reply. 10.8. In the year 2000, what is the difference between the Value added (% of GDP) in Armenia and Value added (% of GDP) in Jordan?
Your answer should be compact. 23.2. In the year 2000, what is the difference between the Value added (% of GDP) in China and Value added (% of GDP) in Jordan?
Keep it short and to the point. 12.4. In the year 2001, what is the difference between the Value added (% of GDP) of Argentina and Value added (% of GDP) of Armenia?
Offer a very short reply. -23.44. In the year 2001, what is the difference between the Value added (% of GDP) in Argentina and Value added (% of GDP) in China?
Your answer should be compact. -9.16. In the year 2001, what is the difference between the Value added (% of GDP) of Argentina and Value added (% of GDP) of Jordan?
Provide a short and direct response. 2.62. In the year 2001, what is the difference between the Value added (% of GDP) in Armenia and Value added (% of GDP) in China?
Offer a terse response. 14.27. In the year 2001, what is the difference between the Value added (% of GDP) of Armenia and Value added (% of GDP) of Jordan?
Give a very brief answer. 26.06. In the year 2001, what is the difference between the Value added (% of GDP) of China and Value added (% of GDP) of Jordan?
Your answer should be very brief. 11.78. In the year 2002, what is the difference between the Value added (% of GDP) in Argentina and Value added (% of GDP) in Armenia?
Your response must be concise. -15.14. In the year 2002, what is the difference between the Value added (% of GDP) in Argentina and Value added (% of GDP) in China?
Keep it short and to the point. -2.56. In the year 2002, what is the difference between the Value added (% of GDP) of Argentina and Value added (% of GDP) of Jordan?
Provide a succinct answer. 8.28. In the year 2002, what is the difference between the Value added (% of GDP) in Armenia and Value added (% of GDP) in China?
Offer a terse response. 12.58. In the year 2002, what is the difference between the Value added (% of GDP) in Armenia and Value added (% of GDP) in Jordan?
Offer a very short reply. 23.42. In the year 2002, what is the difference between the Value added (% of GDP) in China and Value added (% of GDP) in Jordan?
Give a very brief answer. 10.83. In the year 2003, what is the difference between the Value added (% of GDP) in Argentina and Value added (% of GDP) in Armenia?
Give a very brief answer. -12.64. In the year 2003, what is the difference between the Value added (% of GDP) in Argentina and Value added (% of GDP) in China?
Offer a terse response. -1.38. In the year 2003, what is the difference between the Value added (% of GDP) in Argentina and Value added (% of GDP) in Jordan?
Your response must be concise. 8.21. In the year 2003, what is the difference between the Value added (% of GDP) of Armenia and Value added (% of GDP) of China?
Provide a short and direct response. 11.26. In the year 2003, what is the difference between the Value added (% of GDP) of Armenia and Value added (% of GDP) of Jordan?
Ensure brevity in your answer.  20.85. In the year 2003, what is the difference between the Value added (% of GDP) of China and Value added (% of GDP) of Jordan?
Provide a succinct answer. 9.6. In the year 2004, what is the difference between the Value added (% of GDP) of Argentina and Value added (% of GDP) of Armenia?
Your answer should be compact. -15.65. In the year 2004, what is the difference between the Value added (% of GDP) of Argentina and Value added (% of GDP) of China?
Make the answer very short. -4. In the year 2004, what is the difference between the Value added (% of GDP) in Argentina and Value added (% of GDP) in Jordan?
Offer a very short reply. 6.2. In the year 2004, what is the difference between the Value added (% of GDP) in Armenia and Value added (% of GDP) in China?
Offer a very short reply. 11.66. In the year 2004, what is the difference between the Value added (% of GDP) in Armenia and Value added (% of GDP) in Jordan?
Offer a terse response. 21.85. In the year 2004, what is the difference between the Value added (% of GDP) in China and Value added (% of GDP) in Jordan?
Give a very brief answer. 10.2. What is the ratio of the Value added (% of GDP) of Armenia in 1997 to that in 1998?
Your answer should be very brief. 0.94. What is the ratio of the Value added (% of GDP) in China in 1997 to that in 1998?
Offer a terse response. 1.04. What is the ratio of the Value added (% of GDP) of Jordan in 1997 to that in 1998?
Offer a very short reply. 1.09. What is the ratio of the Value added (% of GDP) of Argentina in 1997 to that in 1999?
Your answer should be compact. 1.18. What is the ratio of the Value added (% of GDP) in Armenia in 1997 to that in 1999?
Give a very brief answer. 1.08. What is the ratio of the Value added (% of GDP) of China in 1997 to that in 1999?
Provide a short and direct response. 1.11. What is the ratio of the Value added (% of GDP) of Jordan in 1997 to that in 1999?
Your answer should be very brief. 1.4. What is the ratio of the Value added (% of GDP) of Argentina in 1997 to that in 2000?
Offer a very short reply. 1.12. What is the ratio of the Value added (% of GDP) in Armenia in 1997 to that in 2000?
Your answer should be very brief. 1.25. What is the ratio of the Value added (% of GDP) in China in 1997 to that in 2000?
Offer a terse response. 1.22. What is the ratio of the Value added (% of GDP) of Jordan in 1997 to that in 2000?
Make the answer very short. 1.42. What is the ratio of the Value added (% of GDP) of Argentina in 1997 to that in 2001?
Keep it short and to the point. 1.16. What is the ratio of the Value added (% of GDP) of Armenia in 1997 to that in 2001?
Provide a short and direct response. 1.13. What is the ratio of the Value added (% of GDP) in China in 1997 to that in 2001?
Your response must be concise. 1.28. What is the ratio of the Value added (% of GDP) of Jordan in 1997 to that in 2001?
Your answer should be very brief. 1.47. What is the ratio of the Value added (% of GDP) of Argentina in 1997 to that in 2002?
Keep it short and to the point. 0.52. What is the ratio of the Value added (% of GDP) of Armenia in 1997 to that in 2002?
Ensure brevity in your answer.  1.23. What is the ratio of the Value added (% of GDP) of China in 1997 to that in 2002?
Provide a short and direct response. 1.34. What is the ratio of the Value added (% of GDP) in Jordan in 1997 to that in 2002?
Offer a terse response. 1.31. What is the ratio of the Value added (% of GDP) of Argentina in 1997 to that in 2003?
Your answer should be compact. 0.51. What is the ratio of the Value added (% of GDP) in Armenia in 1997 to that in 2003?
Ensure brevity in your answer.  1.35. What is the ratio of the Value added (% of GDP) of China in 1997 to that in 2003?
Ensure brevity in your answer.  1.45. What is the ratio of the Value added (% of GDP) in Jordan in 1997 to that in 2003?
Keep it short and to the point. 1.18. What is the ratio of the Value added (% of GDP) in Argentina in 1997 to that in 2004?
Your answer should be very brief. 0.63. What is the ratio of the Value added (% of GDP) of Armenia in 1997 to that in 2004?
Your answer should be compact. 1.3. What is the ratio of the Value added (% of GDP) of China in 1997 to that in 2004?
Offer a very short reply. 1.38. What is the ratio of the Value added (% of GDP) in Jordan in 1997 to that in 2004?
Your response must be concise. 1.19. What is the ratio of the Value added (% of GDP) in Argentina in 1998 to that in 1999?
Keep it short and to the point. 1.18. What is the ratio of the Value added (% of GDP) in Armenia in 1998 to that in 1999?
Your answer should be compact. 1.15. What is the ratio of the Value added (% of GDP) in China in 1998 to that in 1999?
Give a very brief answer. 1.07. What is the ratio of the Value added (% of GDP) in Jordan in 1998 to that in 1999?
Make the answer very short. 1.29. What is the ratio of the Value added (% of GDP) in Argentina in 1998 to that in 2000?
Provide a succinct answer. 1.13. What is the ratio of the Value added (% of GDP) of Armenia in 1998 to that in 2000?
Give a very brief answer. 1.33. What is the ratio of the Value added (% of GDP) of China in 1998 to that in 2000?
Offer a terse response. 1.17. What is the ratio of the Value added (% of GDP) in Jordan in 1998 to that in 2000?
Make the answer very short. 1.31. What is the ratio of the Value added (% of GDP) of Argentina in 1998 to that in 2001?
Your answer should be very brief. 1.17. What is the ratio of the Value added (% of GDP) in Armenia in 1998 to that in 2001?
Your answer should be compact. 1.2. What is the ratio of the Value added (% of GDP) in China in 1998 to that in 2001?
Provide a succinct answer. 1.23. What is the ratio of the Value added (% of GDP) of Jordan in 1998 to that in 2001?
Your answer should be very brief. 1.35. What is the ratio of the Value added (% of GDP) of Argentina in 1998 to that in 2002?
Give a very brief answer. 0.53. What is the ratio of the Value added (% of GDP) of Armenia in 1998 to that in 2002?
Your response must be concise. 1.31. What is the ratio of the Value added (% of GDP) of China in 1998 to that in 2002?
Offer a very short reply. 1.29. What is the ratio of the Value added (% of GDP) in Jordan in 1998 to that in 2002?
Provide a succinct answer. 1.2. What is the ratio of the Value added (% of GDP) of Argentina in 1998 to that in 2003?
Your response must be concise. 0.52. What is the ratio of the Value added (% of GDP) of Armenia in 1998 to that in 2003?
Ensure brevity in your answer.  1.44. What is the ratio of the Value added (% of GDP) in China in 1998 to that in 2003?
Ensure brevity in your answer.  1.39. What is the ratio of the Value added (% of GDP) of Jordan in 1998 to that in 2003?
Keep it short and to the point. 1.08. What is the ratio of the Value added (% of GDP) of Argentina in 1998 to that in 2004?
Ensure brevity in your answer.  0.63. What is the ratio of the Value added (% of GDP) of Armenia in 1998 to that in 2004?
Offer a terse response. 1.38. What is the ratio of the Value added (% of GDP) of China in 1998 to that in 2004?
Your answer should be compact. 1.32. What is the ratio of the Value added (% of GDP) in Jordan in 1998 to that in 2004?
Your response must be concise. 1.09. What is the ratio of the Value added (% of GDP) of Argentina in 1999 to that in 2000?
Keep it short and to the point. 0.95. What is the ratio of the Value added (% of GDP) of Armenia in 1999 to that in 2000?
Give a very brief answer. 1.15. What is the ratio of the Value added (% of GDP) in China in 1999 to that in 2000?
Give a very brief answer. 1.09. What is the ratio of the Value added (% of GDP) in Jordan in 1999 to that in 2000?
Your answer should be very brief. 1.02. What is the ratio of the Value added (% of GDP) in Argentina in 1999 to that in 2001?
Provide a short and direct response. 0.98. What is the ratio of the Value added (% of GDP) of Armenia in 1999 to that in 2001?
Offer a terse response. 1.04. What is the ratio of the Value added (% of GDP) in China in 1999 to that in 2001?
Give a very brief answer. 1.15. What is the ratio of the Value added (% of GDP) of Jordan in 1999 to that in 2001?
Your answer should be very brief. 1.05. What is the ratio of the Value added (% of GDP) of Argentina in 1999 to that in 2002?
Provide a succinct answer. 0.45. What is the ratio of the Value added (% of GDP) in Armenia in 1999 to that in 2002?
Your answer should be very brief. 1.13. What is the ratio of the Value added (% of GDP) of China in 1999 to that in 2002?
Your answer should be very brief. 1.21. What is the ratio of the Value added (% of GDP) in Jordan in 1999 to that in 2002?
Keep it short and to the point. 0.94. What is the ratio of the Value added (% of GDP) of Argentina in 1999 to that in 2003?
Provide a succinct answer. 0.44. What is the ratio of the Value added (% of GDP) of Armenia in 1999 to that in 2003?
Provide a short and direct response. 1.24. What is the ratio of the Value added (% of GDP) in China in 1999 to that in 2003?
Ensure brevity in your answer.  1.3. What is the ratio of the Value added (% of GDP) of Jordan in 1999 to that in 2003?
Give a very brief answer. 0.84. What is the ratio of the Value added (% of GDP) in Argentina in 1999 to that in 2004?
Your answer should be very brief. 0.53. What is the ratio of the Value added (% of GDP) in Armenia in 1999 to that in 2004?
Give a very brief answer. 1.19. What is the ratio of the Value added (% of GDP) in China in 1999 to that in 2004?
Your response must be concise. 1.24. What is the ratio of the Value added (% of GDP) in Jordan in 1999 to that in 2004?
Provide a succinct answer. 0.85. What is the ratio of the Value added (% of GDP) of Argentina in 2000 to that in 2001?
Provide a succinct answer. 1.03. What is the ratio of the Value added (% of GDP) of Armenia in 2000 to that in 2001?
Keep it short and to the point. 0.9. What is the ratio of the Value added (% of GDP) of China in 2000 to that in 2001?
Offer a terse response. 1.05. What is the ratio of the Value added (% of GDP) of Jordan in 2000 to that in 2001?
Give a very brief answer. 1.03. What is the ratio of the Value added (% of GDP) of Argentina in 2000 to that in 2002?
Your response must be concise. 0.47. What is the ratio of the Value added (% of GDP) in Armenia in 2000 to that in 2002?
Provide a short and direct response. 0.98. What is the ratio of the Value added (% of GDP) in China in 2000 to that in 2002?
Make the answer very short. 1.1. What is the ratio of the Value added (% of GDP) of Jordan in 2000 to that in 2002?
Make the answer very short. 0.92. What is the ratio of the Value added (% of GDP) of Argentina in 2000 to that in 2003?
Offer a very short reply. 0.46. What is the ratio of the Value added (% of GDP) of Armenia in 2000 to that in 2003?
Your response must be concise. 1.08. What is the ratio of the Value added (% of GDP) of China in 2000 to that in 2003?
Ensure brevity in your answer.  1.19. What is the ratio of the Value added (% of GDP) of Jordan in 2000 to that in 2003?
Your answer should be compact. 0.83. What is the ratio of the Value added (% of GDP) in Argentina in 2000 to that in 2004?
Your answer should be very brief. 0.56. What is the ratio of the Value added (% of GDP) of Armenia in 2000 to that in 2004?
Provide a short and direct response. 1.04. What is the ratio of the Value added (% of GDP) of China in 2000 to that in 2004?
Offer a terse response. 1.13. What is the ratio of the Value added (% of GDP) of Jordan in 2000 to that in 2004?
Offer a terse response. 0.84. What is the ratio of the Value added (% of GDP) of Argentina in 2001 to that in 2002?
Provide a succinct answer. 0.45. What is the ratio of the Value added (% of GDP) in Armenia in 2001 to that in 2002?
Give a very brief answer. 1.09. What is the ratio of the Value added (% of GDP) of China in 2001 to that in 2002?
Your response must be concise. 1.05. What is the ratio of the Value added (% of GDP) in Jordan in 2001 to that in 2002?
Your response must be concise. 0.89. What is the ratio of the Value added (% of GDP) of Argentina in 2001 to that in 2003?
Provide a short and direct response. 0.44. What is the ratio of the Value added (% of GDP) in Armenia in 2001 to that in 2003?
Keep it short and to the point. 1.2. What is the ratio of the Value added (% of GDP) in China in 2001 to that in 2003?
Your response must be concise. 1.13. What is the ratio of the Value added (% of GDP) in Jordan in 2001 to that in 2003?
Give a very brief answer. 0.8. What is the ratio of the Value added (% of GDP) in Argentina in 2001 to that in 2004?
Give a very brief answer. 0.54. What is the ratio of the Value added (% of GDP) of Armenia in 2001 to that in 2004?
Your answer should be very brief. 1.15. What is the ratio of the Value added (% of GDP) of China in 2001 to that in 2004?
Offer a very short reply. 1.08. What is the ratio of the Value added (% of GDP) in Jordan in 2001 to that in 2004?
Provide a short and direct response. 0.81. What is the ratio of the Value added (% of GDP) in Argentina in 2002 to that in 2003?
Offer a very short reply. 0.98. What is the ratio of the Value added (% of GDP) in Armenia in 2002 to that in 2003?
Give a very brief answer. 1.1. What is the ratio of the Value added (% of GDP) of China in 2002 to that in 2003?
Keep it short and to the point. 1.08. What is the ratio of the Value added (% of GDP) of Jordan in 2002 to that in 2003?
Your answer should be compact. 0.9. What is the ratio of the Value added (% of GDP) in Argentina in 2002 to that in 2004?
Ensure brevity in your answer.  1.2. What is the ratio of the Value added (% of GDP) of Armenia in 2002 to that in 2004?
Give a very brief answer. 1.05. What is the ratio of the Value added (% of GDP) of China in 2002 to that in 2004?
Your answer should be compact. 1.03. What is the ratio of the Value added (% of GDP) of Jordan in 2002 to that in 2004?
Offer a very short reply. 0.91. What is the ratio of the Value added (% of GDP) of Argentina in 2003 to that in 2004?
Give a very brief answer. 1.23. What is the ratio of the Value added (% of GDP) of Armenia in 2003 to that in 2004?
Your answer should be compact. 0.96. What is the ratio of the Value added (% of GDP) in China in 2003 to that in 2004?
Make the answer very short. 0.96. What is the ratio of the Value added (% of GDP) of Jordan in 2003 to that in 2004?
Your answer should be very brief. 1.01. What is the difference between the highest and the second highest Value added (% of GDP) of Argentina?
Your answer should be very brief. 0.22. What is the difference between the highest and the second highest Value added (% of GDP) in Armenia?
Provide a short and direct response. 2.03. What is the difference between the highest and the second highest Value added (% of GDP) of China?
Keep it short and to the point. 0.74. What is the difference between the highest and the second highest Value added (% of GDP) in Jordan?
Provide a succinct answer. 0.27. What is the difference between the highest and the lowest Value added (% of GDP) in Argentina?
Keep it short and to the point. 6.23. What is the difference between the highest and the lowest Value added (% of GDP) of Armenia?
Ensure brevity in your answer.  10.31. What is the difference between the highest and the lowest Value added (% of GDP) in China?
Make the answer very short. 5.53. What is the difference between the highest and the lowest Value added (% of GDP) in Jordan?
Give a very brief answer. 1.06. 